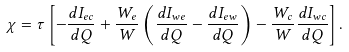Convert formula to latex. <formula><loc_0><loc_0><loc_500><loc_500>\chi = \tau \left [ - \frac { d I _ { e c } } { d Q } + \frac { W _ { e } } { W } \left ( \frac { d I _ { w e } } { d Q } - \frac { d I _ { e w } } { d Q } \right ) - \frac { W _ { c } } { W } \frac { d I _ { w c } } { d Q } \right ] .</formula> 